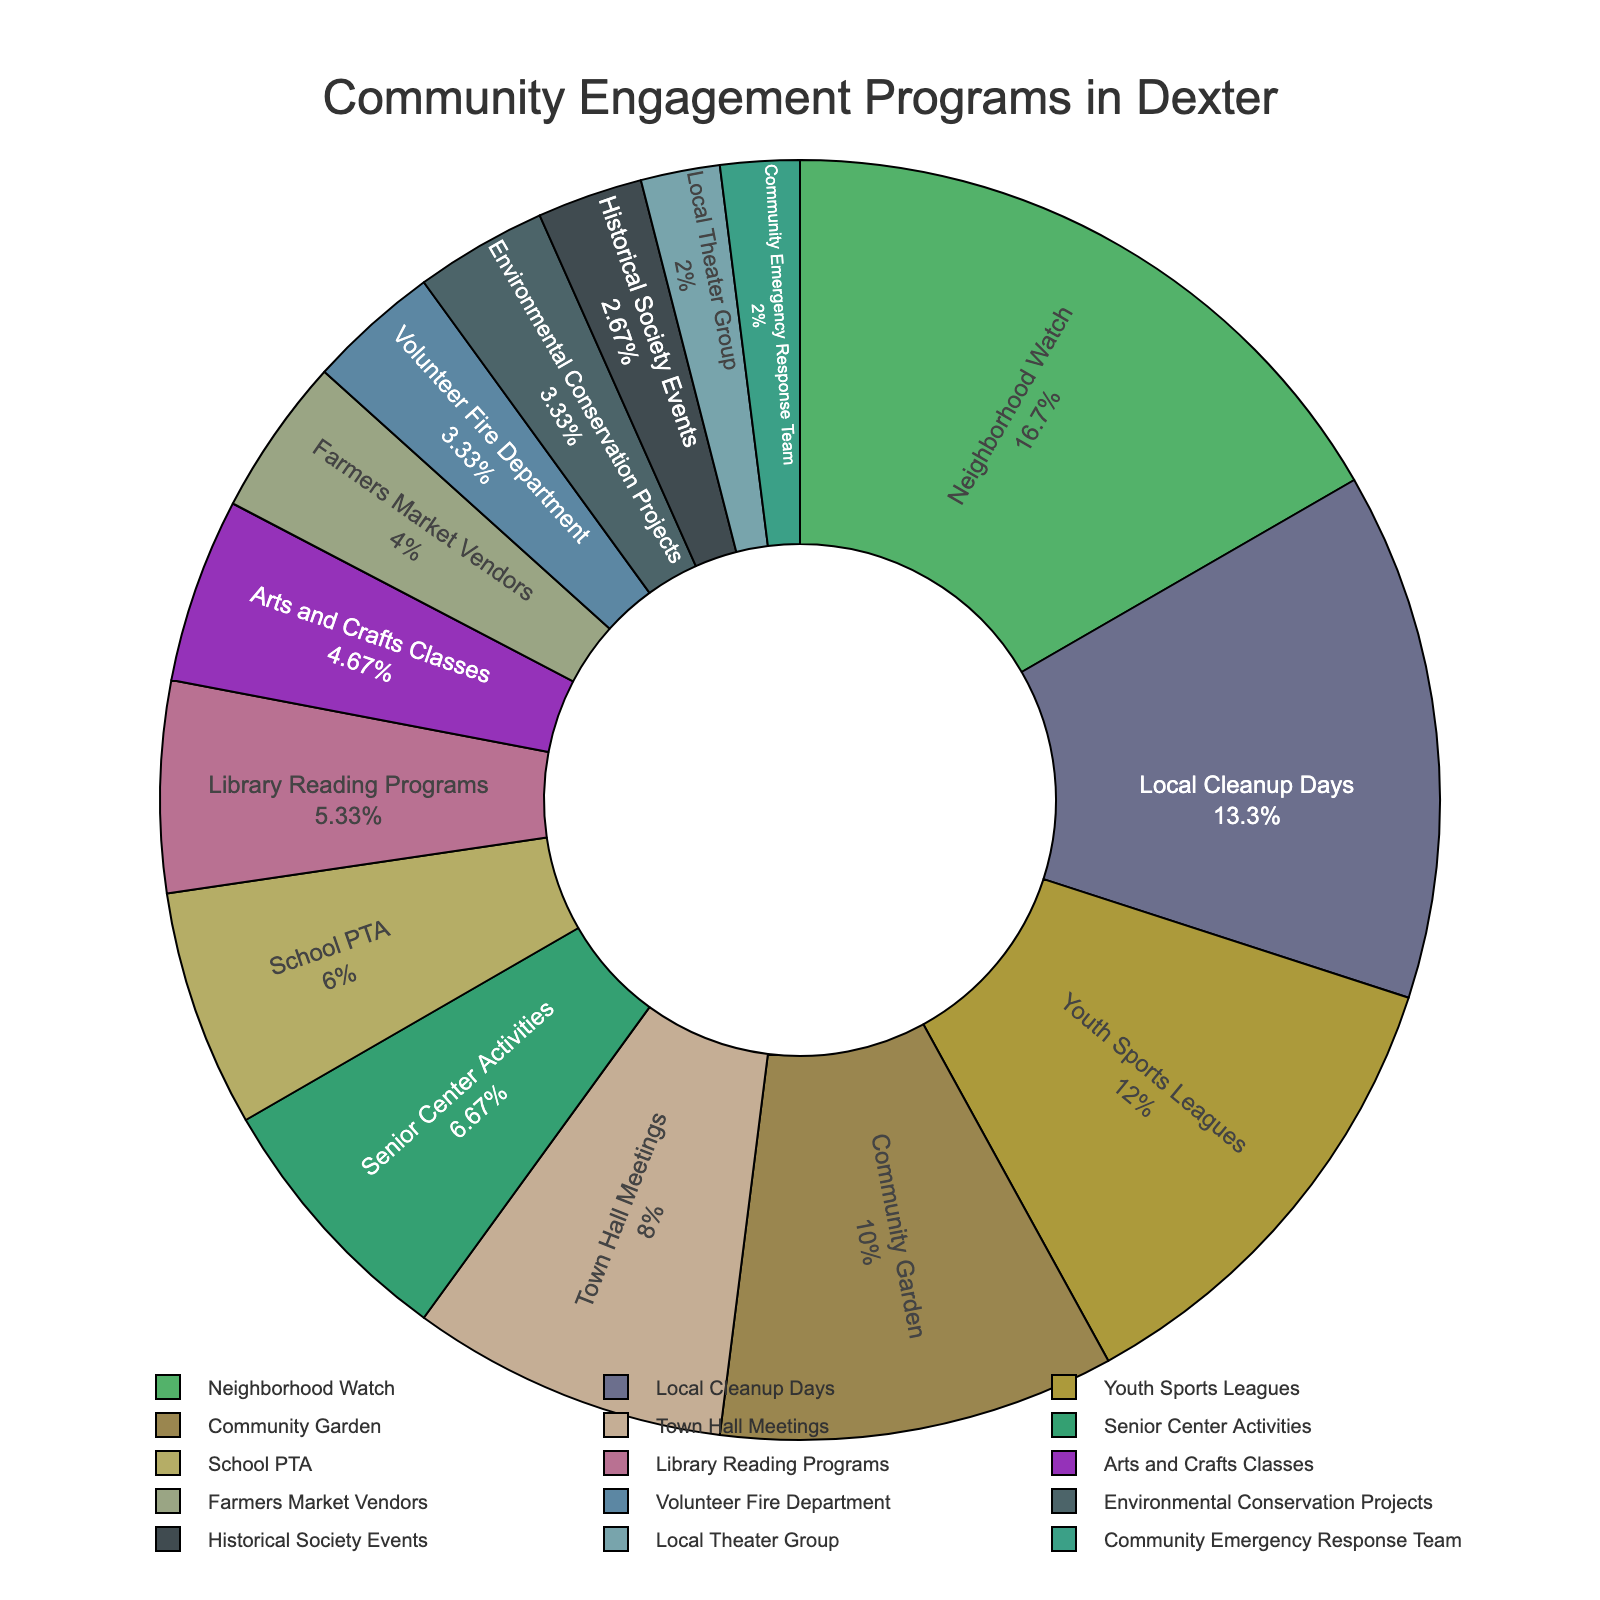Which program has the highest participation rate? By examining the pie chart, the segment corresponding to "Neighborhood Watch" is the largest, indicating the highest participation rate.
Answer: Neighborhood Watch Which program has the lowest participation rate? The smallest segment in the pie chart corresponds to the "Local Theater Group."
Answer: Local Theater Group What is the combined participation rate of the Youth Sports Leagues and Senior Center Activities? According to the chart, Youth Sports Leagues has a participation rate of 18 and Senior Center Activities has 10. Adding these together gives 28.
Answer: 28 How does the participation rate of the Community Garden compare to that of the Farmers Market Vendors? Examining the pie chart, Community Garden has a larger segment than Farmers Market Vendors, indicating a higher participation rate.
Answer: Community Garden has a higher rate Which program has a higher participation rate, Local Cleanup Days or Library Reading Programs? The pie chart shows that the segment for Local Cleanup Days is larger than that for Library Reading Programs.
Answer: Local Cleanup Days What is the total participation rate for programs with more than 15% participation? The programs with more than 15% participation are Neighborhood Watch (25), Local Cleanup Days (20), and Youth Sports Leagues (18). Summing these values yields 63.
Answer: 63 Is the participation rate of the Community Emergency Response Team greater or less than that of Environmental Conservation Projects? According to the chart, both Community Emergency Response Team and Environmental Conservation Projects have very similar, small segments, but Environmental Conservation Projects might appear slightly larger.
Answer: Less Which colors represent the segments for the School PTA and Volunteer Fire Department? Based on the visual attributes of the pie chart, the segment for School PTA has a distinct color, as does the Volunteer Fire Department segment. Identifying these colors directly from the chart would provide the specific answer.
Answer: Variable colors (visually distinguishable on the chart) What is the difference in participation rates between Town Hall Meetings and Arts and Crafts Classes? The chart shows Town Hall Meetings with a rate of 12 and Arts and Crafts Classes with 7. Subtracting these two values gives 5.
Answer: 5 Compare the sizes of the segments for Historical Society Events and Community Garden based on their participation rates. The Community Garden segment is noticeably larger than the Historical Society Events segment, indicating a higher participation rate for the former.
Answer: Community Garden's segment is larger 